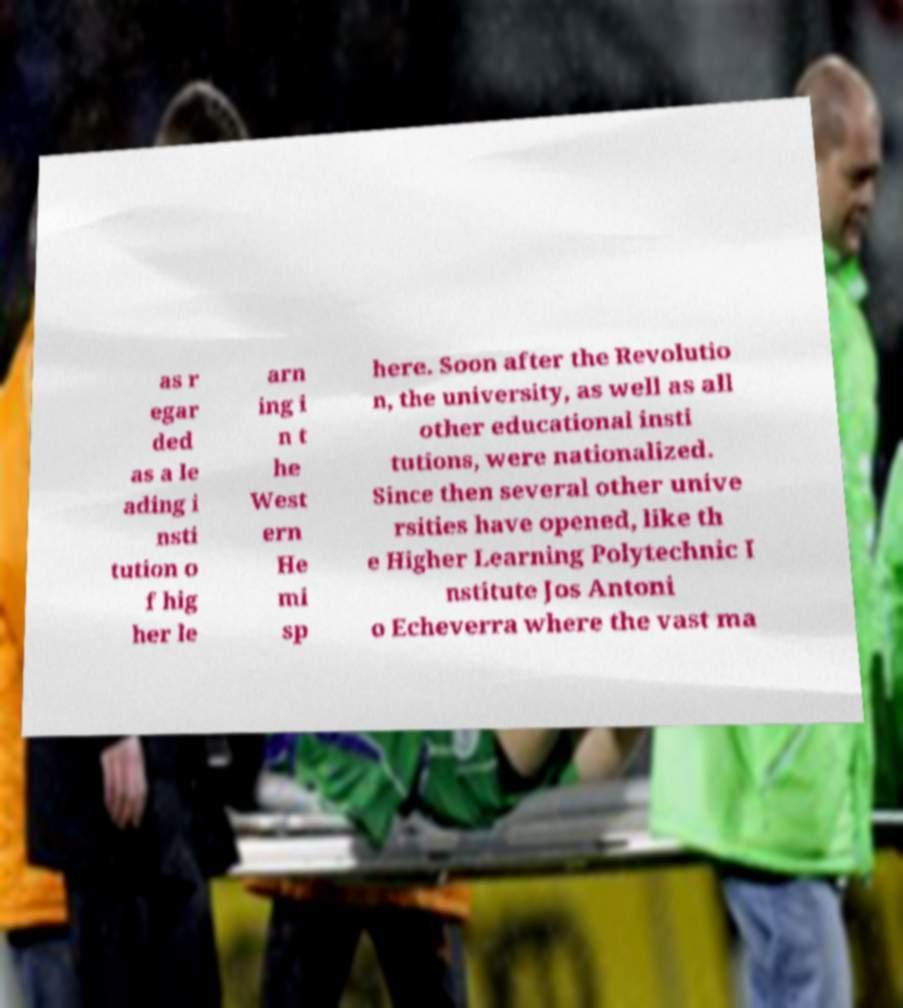There's text embedded in this image that I need extracted. Can you transcribe it verbatim? as r egar ded as a le ading i nsti tution o f hig her le arn ing i n t he West ern He mi sp here. Soon after the Revolutio n, the university, as well as all other educational insti tutions, were nationalized. Since then several other unive rsities have opened, like th e Higher Learning Polytechnic I nstitute Jos Antoni o Echeverra where the vast ma 